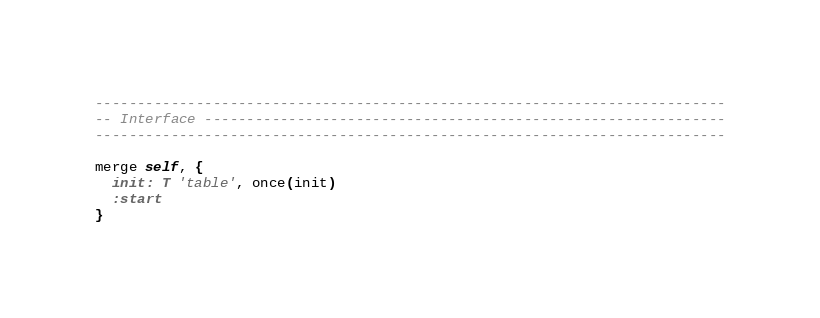<code> <loc_0><loc_0><loc_500><loc_500><_MoonScript_>---------------------------------------------------------------------------
-- Interface --------------------------------------------------------------
---------------------------------------------------------------------------

merge self, {
  init: T 'table', once(init)
  :start
}
</code> 